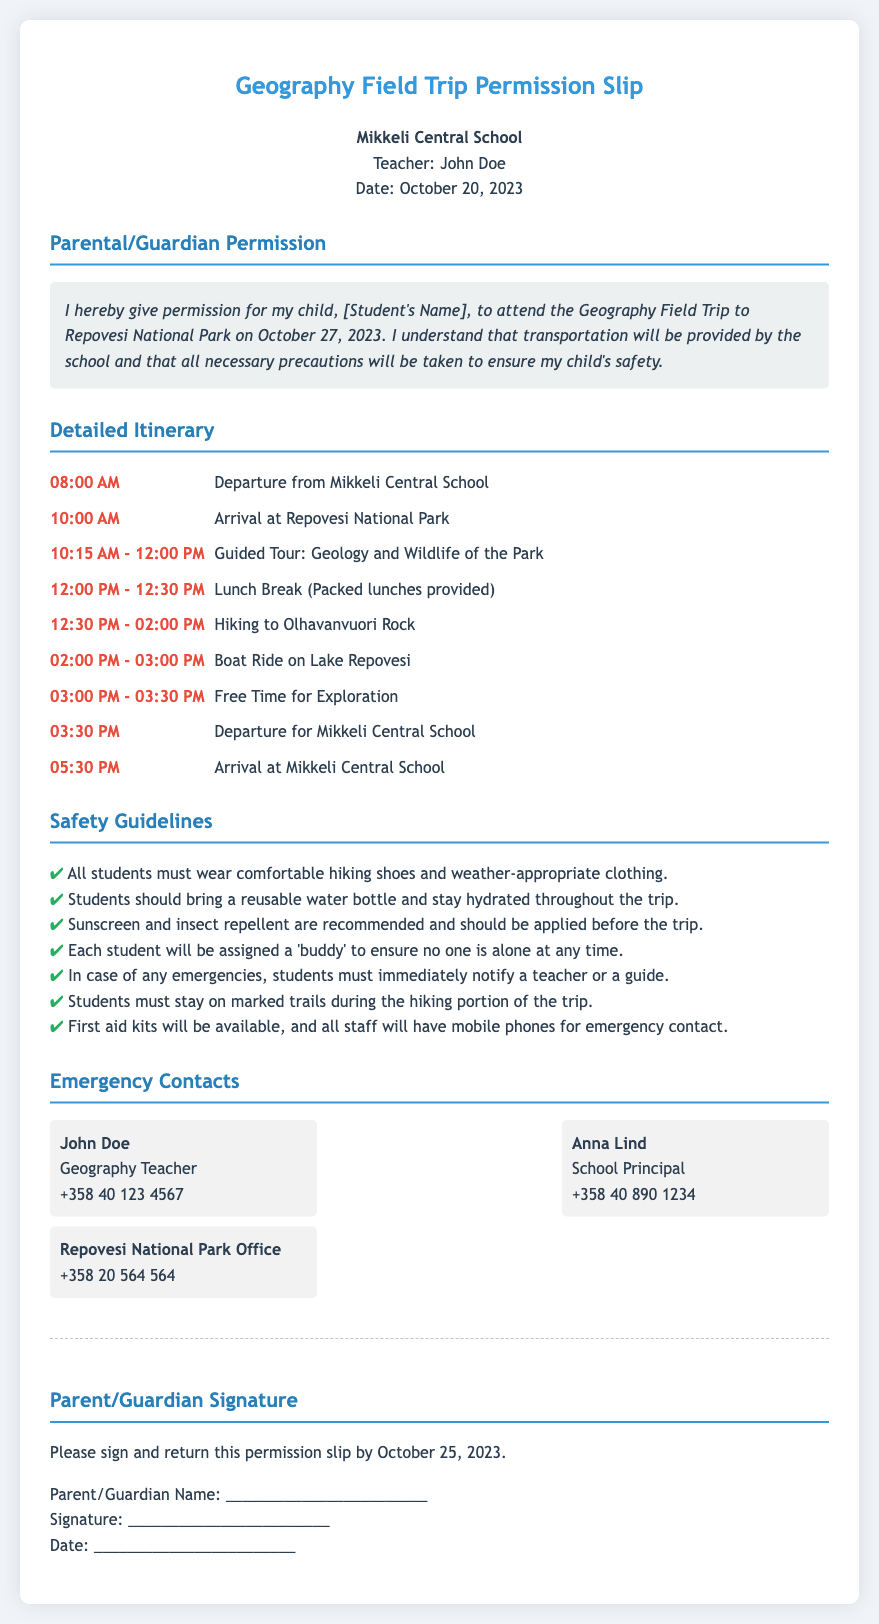What is the location of the field trip? The location of the field trip is mentioned in the document as Repovesi National Park.
Answer: Repovesi National Park What is the departure time from Mikkeli Central School? The document provides a specific itinerary detail stating the departure time is at 08:00 AM.
Answer: 08:00 AM Who is the teacher in charge of the trip? The document lists the teacher in charge as John Doe.
Answer: John Doe What items should students bring for the trip? The safety guidelines mention that students must bring a reusable water bottle.
Answer: Reusable water bottle What should students wear for the trip? The safety guidelines specify that students must wear comfortable hiking shoes.
Answer: Comfortable hiking shoes When should the permission slip be returned? The document states that the permission slip should be returned by October 25, 2023.
Answer: October 25, 2023 What is the first activity after arriving at the park? The detailed itinerary indicates that the first activity is a guided tour on the geology and wildlife of the park.
Answer: Guided Tour: Geology and Wildlife of the Park What is the emergency contact number for the Geography Teacher? The document provides a specific phone number under the emergency contacts for the teacher: +358 40 123 4567.
Answer: +358 40 123 4567 How long is the lunch break? According to the itinerary, the lunch break is scheduled for 30 minutes.
Answer: 30 minutes 